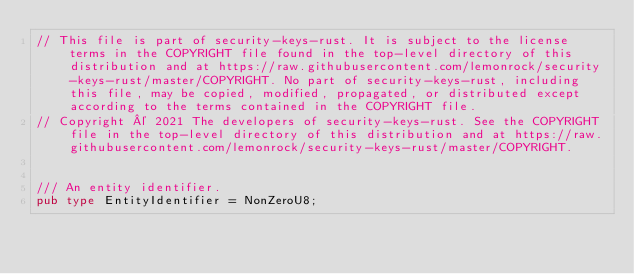<code> <loc_0><loc_0><loc_500><loc_500><_Rust_>// This file is part of security-keys-rust. It is subject to the license terms in the COPYRIGHT file found in the top-level directory of this distribution and at https://raw.githubusercontent.com/lemonrock/security-keys-rust/master/COPYRIGHT. No part of security-keys-rust, including this file, may be copied, modified, propagated, or distributed except according to the terms contained in the COPYRIGHT file.
// Copyright © 2021 The developers of security-keys-rust. See the COPYRIGHT file in the top-level directory of this distribution and at https://raw.githubusercontent.com/lemonrock/security-keys-rust/master/COPYRIGHT.


/// An entity identifier.
pub type EntityIdentifier = NonZeroU8;
</code> 